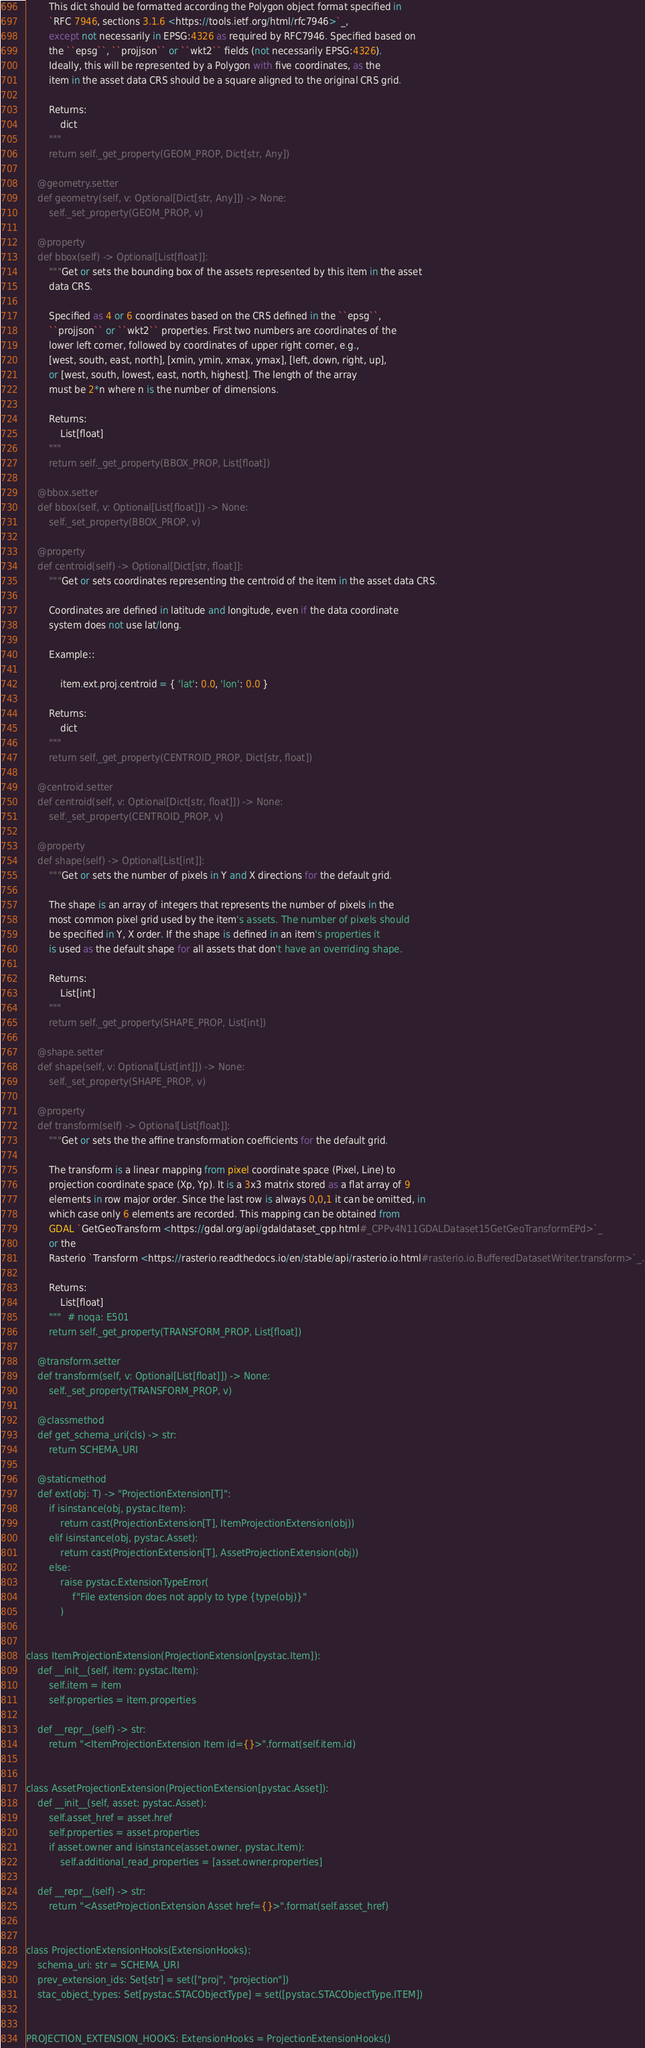Convert code to text. <code><loc_0><loc_0><loc_500><loc_500><_Python_>        This dict should be formatted according the Polygon object format specified in
        `RFC 7946, sections 3.1.6 <https://tools.ietf.org/html/rfc7946>`_,
        except not necessarily in EPSG:4326 as required by RFC7946. Specified based on
        the ``epsg``, ``projjson`` or ``wkt2`` fields (not necessarily EPSG:4326).
        Ideally, this will be represented by a Polygon with five coordinates, as the
        item in the asset data CRS should be a square aligned to the original CRS grid.

        Returns:
            dict
        """
        return self._get_property(GEOM_PROP, Dict[str, Any])

    @geometry.setter
    def geometry(self, v: Optional[Dict[str, Any]]) -> None:
        self._set_property(GEOM_PROP, v)

    @property
    def bbox(self) -> Optional[List[float]]:
        """Get or sets the bounding box of the assets represented by this item in the asset
        data CRS.

        Specified as 4 or 6 coordinates based on the CRS defined in the ``epsg``,
        ``projjson`` or ``wkt2`` properties. First two numbers are coordinates of the
        lower left corner, followed by coordinates of upper right corner, e.g.,
        [west, south, east, north], [xmin, ymin, xmax, ymax], [left, down, right, up],
        or [west, south, lowest, east, north, highest]. The length of the array
        must be 2*n where n is the number of dimensions.

        Returns:
            List[float]
        """
        return self._get_property(BBOX_PROP, List[float])

    @bbox.setter
    def bbox(self, v: Optional[List[float]]) -> None:
        self._set_property(BBOX_PROP, v)

    @property
    def centroid(self) -> Optional[Dict[str, float]]:
        """Get or sets coordinates representing the centroid of the item in the asset data CRS.

        Coordinates are defined in latitude and longitude, even if the data coordinate
        system does not use lat/long.

        Example::

            item.ext.proj.centroid = { 'lat': 0.0, 'lon': 0.0 }

        Returns:
            dict
        """
        return self._get_property(CENTROID_PROP, Dict[str, float])

    @centroid.setter
    def centroid(self, v: Optional[Dict[str, float]]) -> None:
        self._set_property(CENTROID_PROP, v)

    @property
    def shape(self) -> Optional[List[int]]:
        """Get or sets the number of pixels in Y and X directions for the default grid.

        The shape is an array of integers that represents the number of pixels in the
        most common pixel grid used by the item's assets. The number of pixels should
        be specified in Y, X order. If the shape is defined in an item's properties it
        is used as the default shape for all assets that don't have an overriding shape.

        Returns:
            List[int]
        """
        return self._get_property(SHAPE_PROP, List[int])

    @shape.setter
    def shape(self, v: Optional[List[int]]) -> None:
        self._set_property(SHAPE_PROP, v)

    @property
    def transform(self) -> Optional[List[float]]:
        """Get or sets the the affine transformation coefficients for the default grid.

        The transform is a linear mapping from pixel coordinate space (Pixel, Line) to
        projection coordinate space (Xp, Yp). It is a 3x3 matrix stored as a flat array of 9
        elements in row major order. Since the last row is always 0,0,1 it can be omitted, in
        which case only 6 elements are recorded. This mapping can be obtained from
        GDAL `GetGeoTransform <https://gdal.org/api/gdaldataset_cpp.html#_CPPv4N11GDALDataset15GetGeoTransformEPd>`_
        or the
        Rasterio `Transform <https://rasterio.readthedocs.io/en/stable/api/rasterio.io.html#rasterio.io.BufferedDatasetWriter.transform>`_.

        Returns:
            List[float]
        """  # noqa: E501
        return self._get_property(TRANSFORM_PROP, List[float])

    @transform.setter
    def transform(self, v: Optional[List[float]]) -> None:
        self._set_property(TRANSFORM_PROP, v)

    @classmethod
    def get_schema_uri(cls) -> str:
        return SCHEMA_URI

    @staticmethod
    def ext(obj: T) -> "ProjectionExtension[T]":
        if isinstance(obj, pystac.Item):
            return cast(ProjectionExtension[T], ItemProjectionExtension(obj))
        elif isinstance(obj, pystac.Asset):
            return cast(ProjectionExtension[T], AssetProjectionExtension(obj))
        else:
            raise pystac.ExtensionTypeError(
                f"File extension does not apply to type {type(obj)}"
            )


class ItemProjectionExtension(ProjectionExtension[pystac.Item]):
    def __init__(self, item: pystac.Item):
        self.item = item
        self.properties = item.properties

    def __repr__(self) -> str:
        return "<ItemProjectionExtension Item id={}>".format(self.item.id)


class AssetProjectionExtension(ProjectionExtension[pystac.Asset]):
    def __init__(self, asset: pystac.Asset):
        self.asset_href = asset.href
        self.properties = asset.properties
        if asset.owner and isinstance(asset.owner, pystac.Item):
            self.additional_read_properties = [asset.owner.properties]

    def __repr__(self) -> str:
        return "<AssetProjectionExtension Asset href={}>".format(self.asset_href)


class ProjectionExtensionHooks(ExtensionHooks):
    schema_uri: str = SCHEMA_URI
    prev_extension_ids: Set[str] = set(["proj", "projection"])
    stac_object_types: Set[pystac.STACObjectType] = set([pystac.STACObjectType.ITEM])


PROJECTION_EXTENSION_HOOKS: ExtensionHooks = ProjectionExtensionHooks()
</code> 